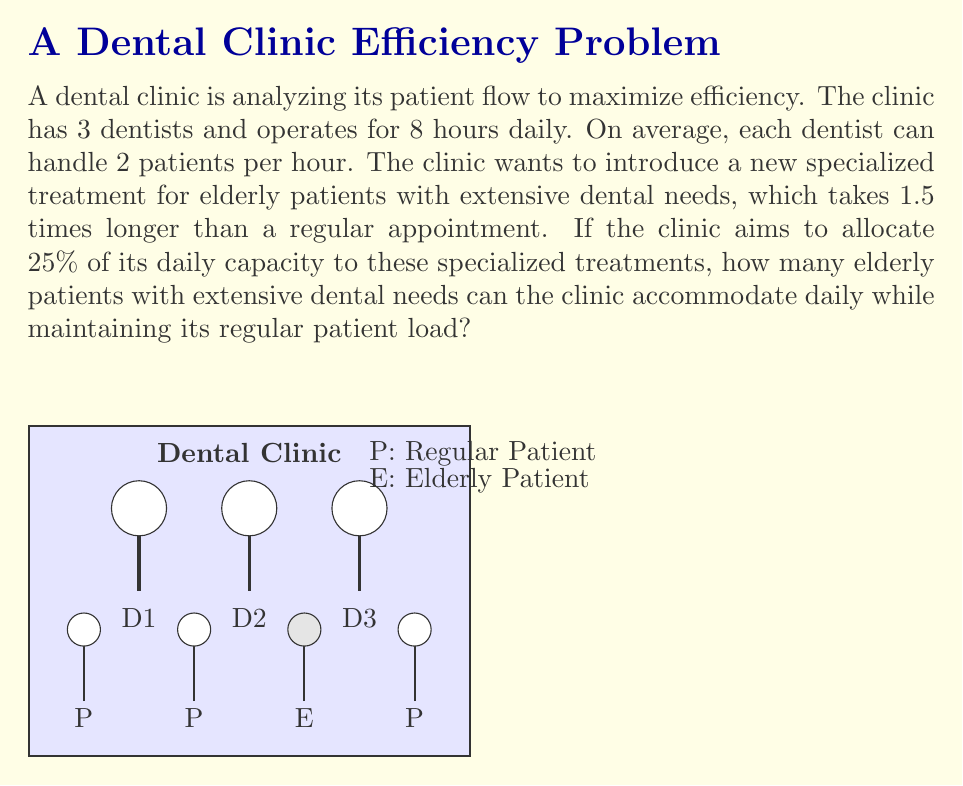Solve this math problem. Let's break this problem down step-by-step:

1) First, calculate the total number of regular patients the clinic can handle daily:
   $$\text{Total regular patients} = 3 \text{ dentists} \times 8 \text{ hours} \times 2 \text{ patients/hour} = 48 \text{ patients}$$

2) The clinic wants to allocate 25% of its capacity to specialized treatments. This means:
   $$\text{Specialized capacity} = 25\% \times 48 = 12 \text{ regular patient slots}$$

3) However, specialized treatments take 1.5 times longer than regular appointments. So, we need to convert these regular slots to specialized slots:
   $$\text{Specialized slots} = \frac{12}{1.5} = 8 \text{ specialized slots}$$

4) Therefore, the clinic can accommodate 8 elderly patients with extensive dental needs daily.

5) Let's verify that this maintains the regular patient load:
   $$\text{Remaining regular slots} = 48 - 12 = 36 \text{ regular patients}$$

So, the clinic can still serve 36 regular patients while accommodating 8 elderly patients with extensive dental needs.
Answer: 8 elderly patients 